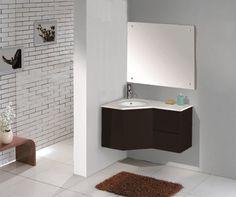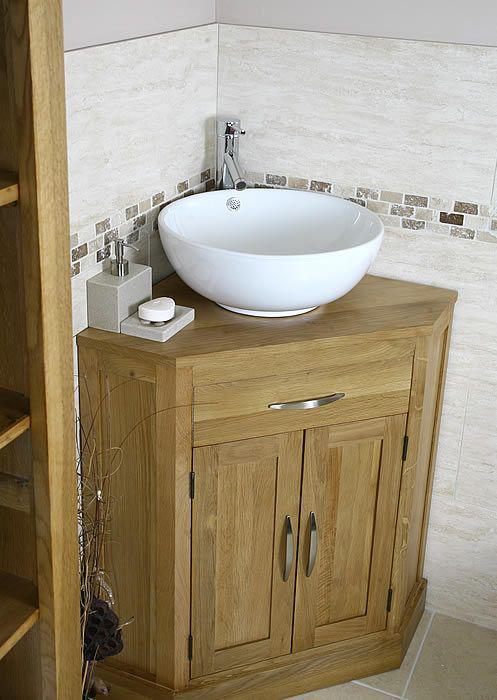The first image is the image on the left, the second image is the image on the right. Analyze the images presented: Is the assertion "One image shows a corner vanity with a white cabinet and an inset sink instead of a vessel sink." valid? Answer yes or no. No. The first image is the image on the left, the second image is the image on the right. Examine the images to the left and right. Is the description "Both sink cabinets are corner units." accurate? Answer yes or no. Yes. 